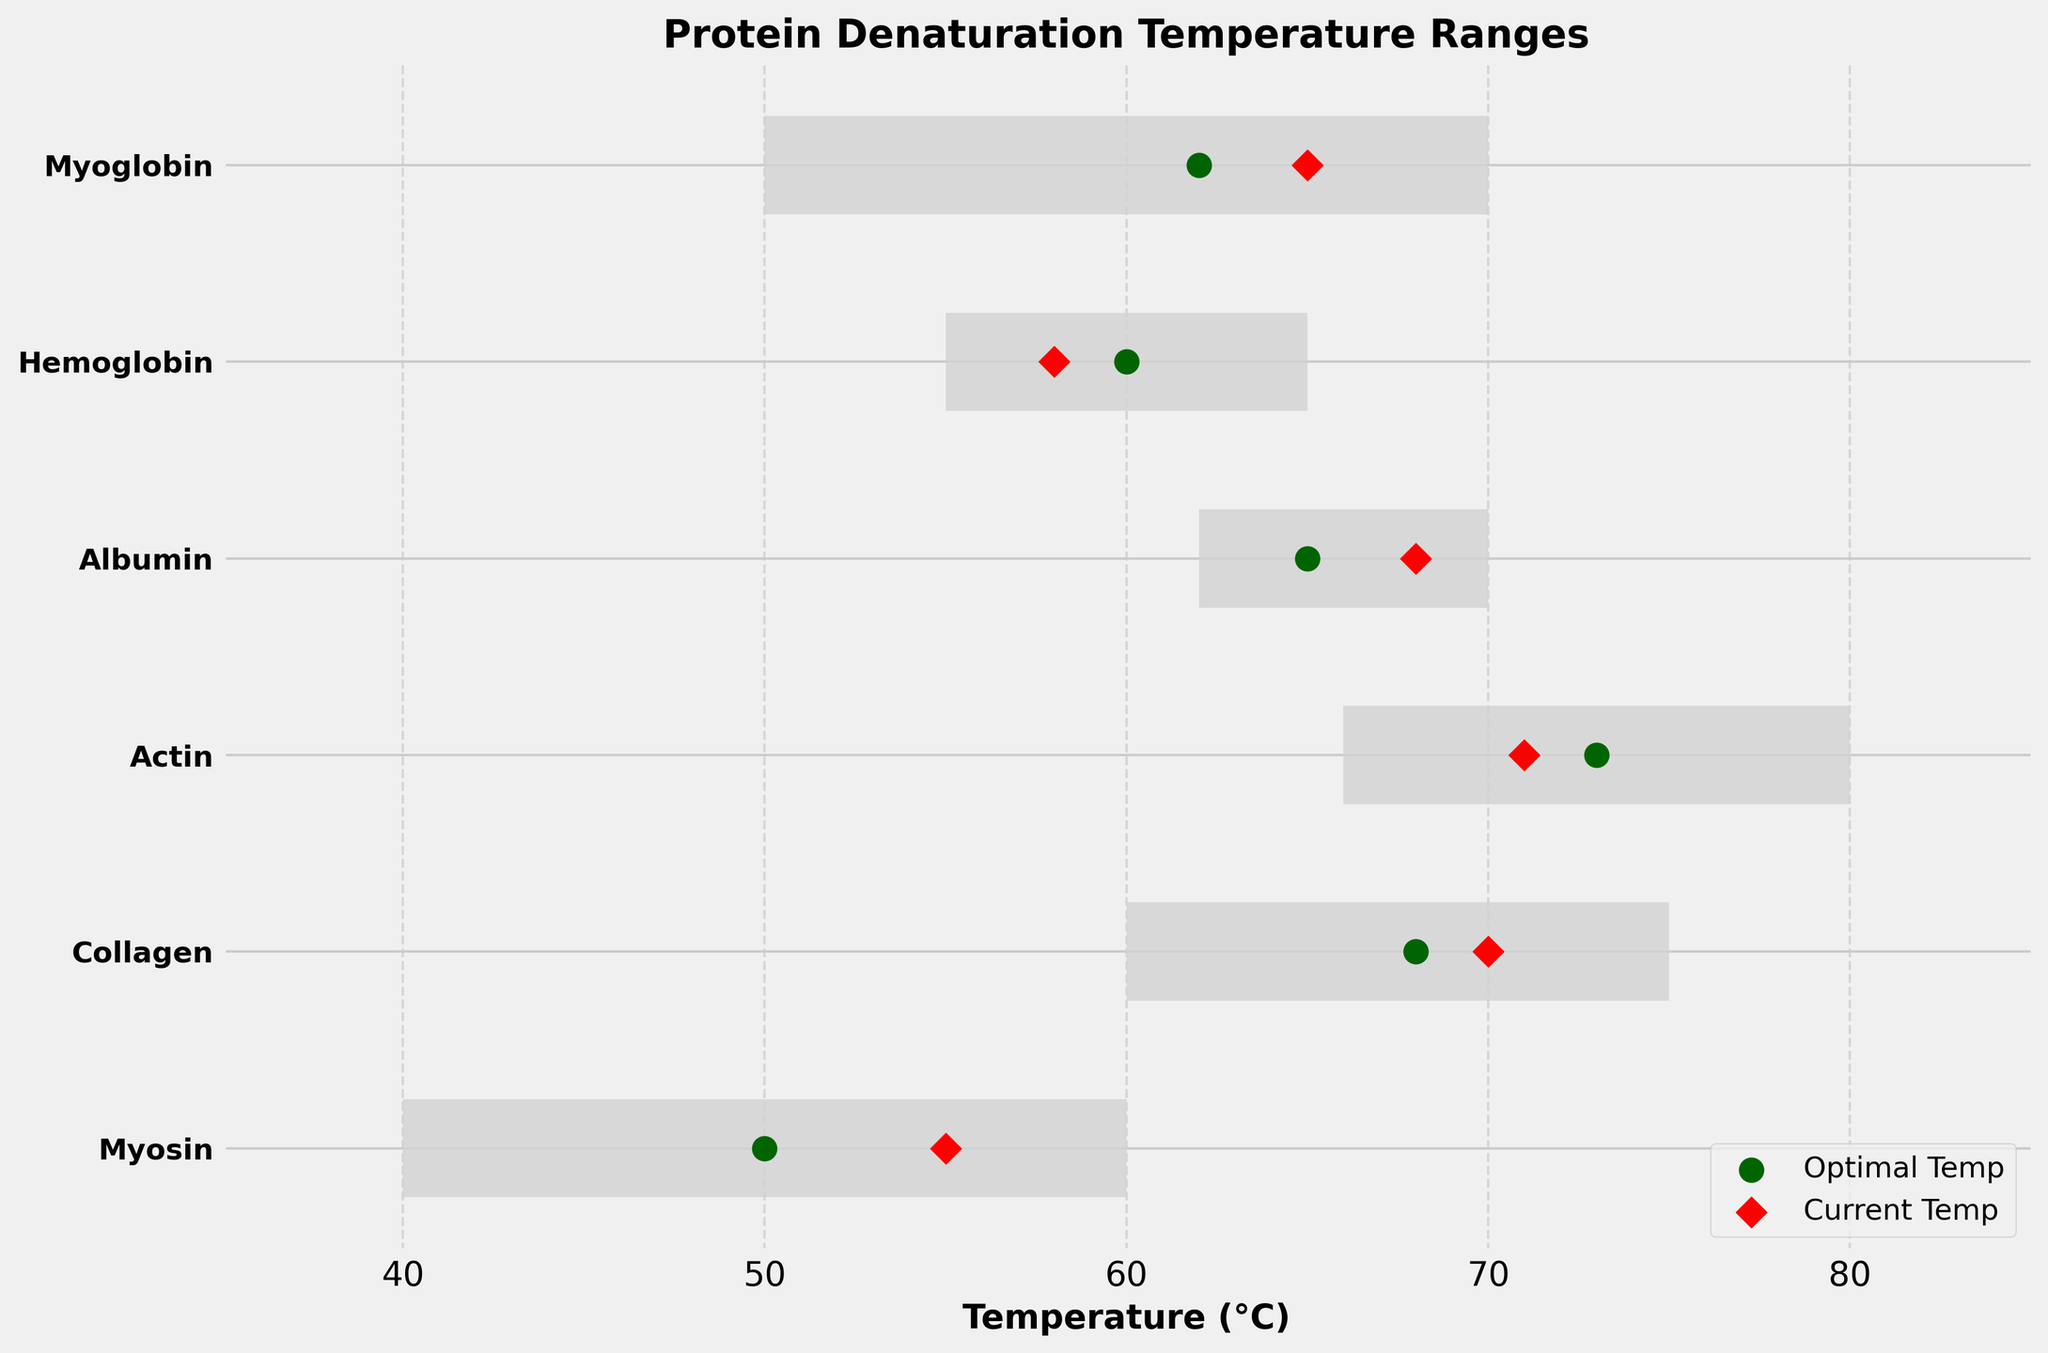What's the title of the chart? The title of the chart is located at the top and is visually prominent in a larger, bold font. It reads "Protein Denaturation Temperature Ranges."
Answer: Protein Denaturation Temperature Ranges What temperature range does Myosin denature at? The temperature range for Myosin is indicated by the horizontal bar corresponding to Myosin on the y-axis. The bar extends from 40°C to 60°C.
Answer: 40°C to 60°C Which protein has the highest current temperature? To determine which protein has the highest current temperature, look at the red diamond markers, which represent current temperatures, and identify the one positioned furthest to the right. The protein "Myoglobin" has the highest current temperature at 65°C.
Answer: Myoglobin What is the optimal temperature for Collagen? The optimal temperature for each protein is marked by a dark green dot. For Collagen, this mark is located on the horizontal axis corresponding to Collagen, positioned at 68°C.
Answer: 68°C How many proteins have their current temperatures above their optimal temperatures? Compare the red diamond markers (current temperatures) and dark green dots (optimal temperatures) for each protein. Myosin (55°C > 50°C), Collagen (70°C > 68°C), and Albumin (68°C > 65°C) have their current temperatures above their optimal temperatures.
Answer: 3 Which protein is closest to its optimal temperature? Calculate the absolute difference between the current temperature and optimal temperature for each protein. Myosin (55-50 = 5), Collagen (70-68 = 2), Actin (71-73 = 2), Albumin (68-65 = 3), Hemoglobin (58-60 = 2), and Myoglobin (65-62 = 3). Collagen, Actin, and Hemoglobin all have a difference of 2, which is the smallest.
Answer: Collagen, Actin, Hemoglobin What is the temperature range for Actin? The horizontal bar for Actin extends from 66°C (minimum temperature) to 80°C (maximum temperature).
Answer: 66°C to 80°C Which protein has the widest denaturation temperature range? The width of each horizontal bar indicates the temperature range. Calculate the difference between the max and min temperatures for each protein: Myosin (60-40 = 20), Collagen (75-60 = 15), Actin (80-66 = 14), Albumin (70-62 = 8), Hemoglobin (65-55 = 10), Myoglobin (70-50 = 20). Both Myosin and Myoglobin have the widest range of 20°C.
Answer: Myosin, Myoglobin What is the average optimal temperature of all proteins? Sum the optimal temperatures and divide by the number of proteins. (50 + 68 + 73 + 65 + 60 + 62) / 6 = 63°C.
Answer: 63°C 